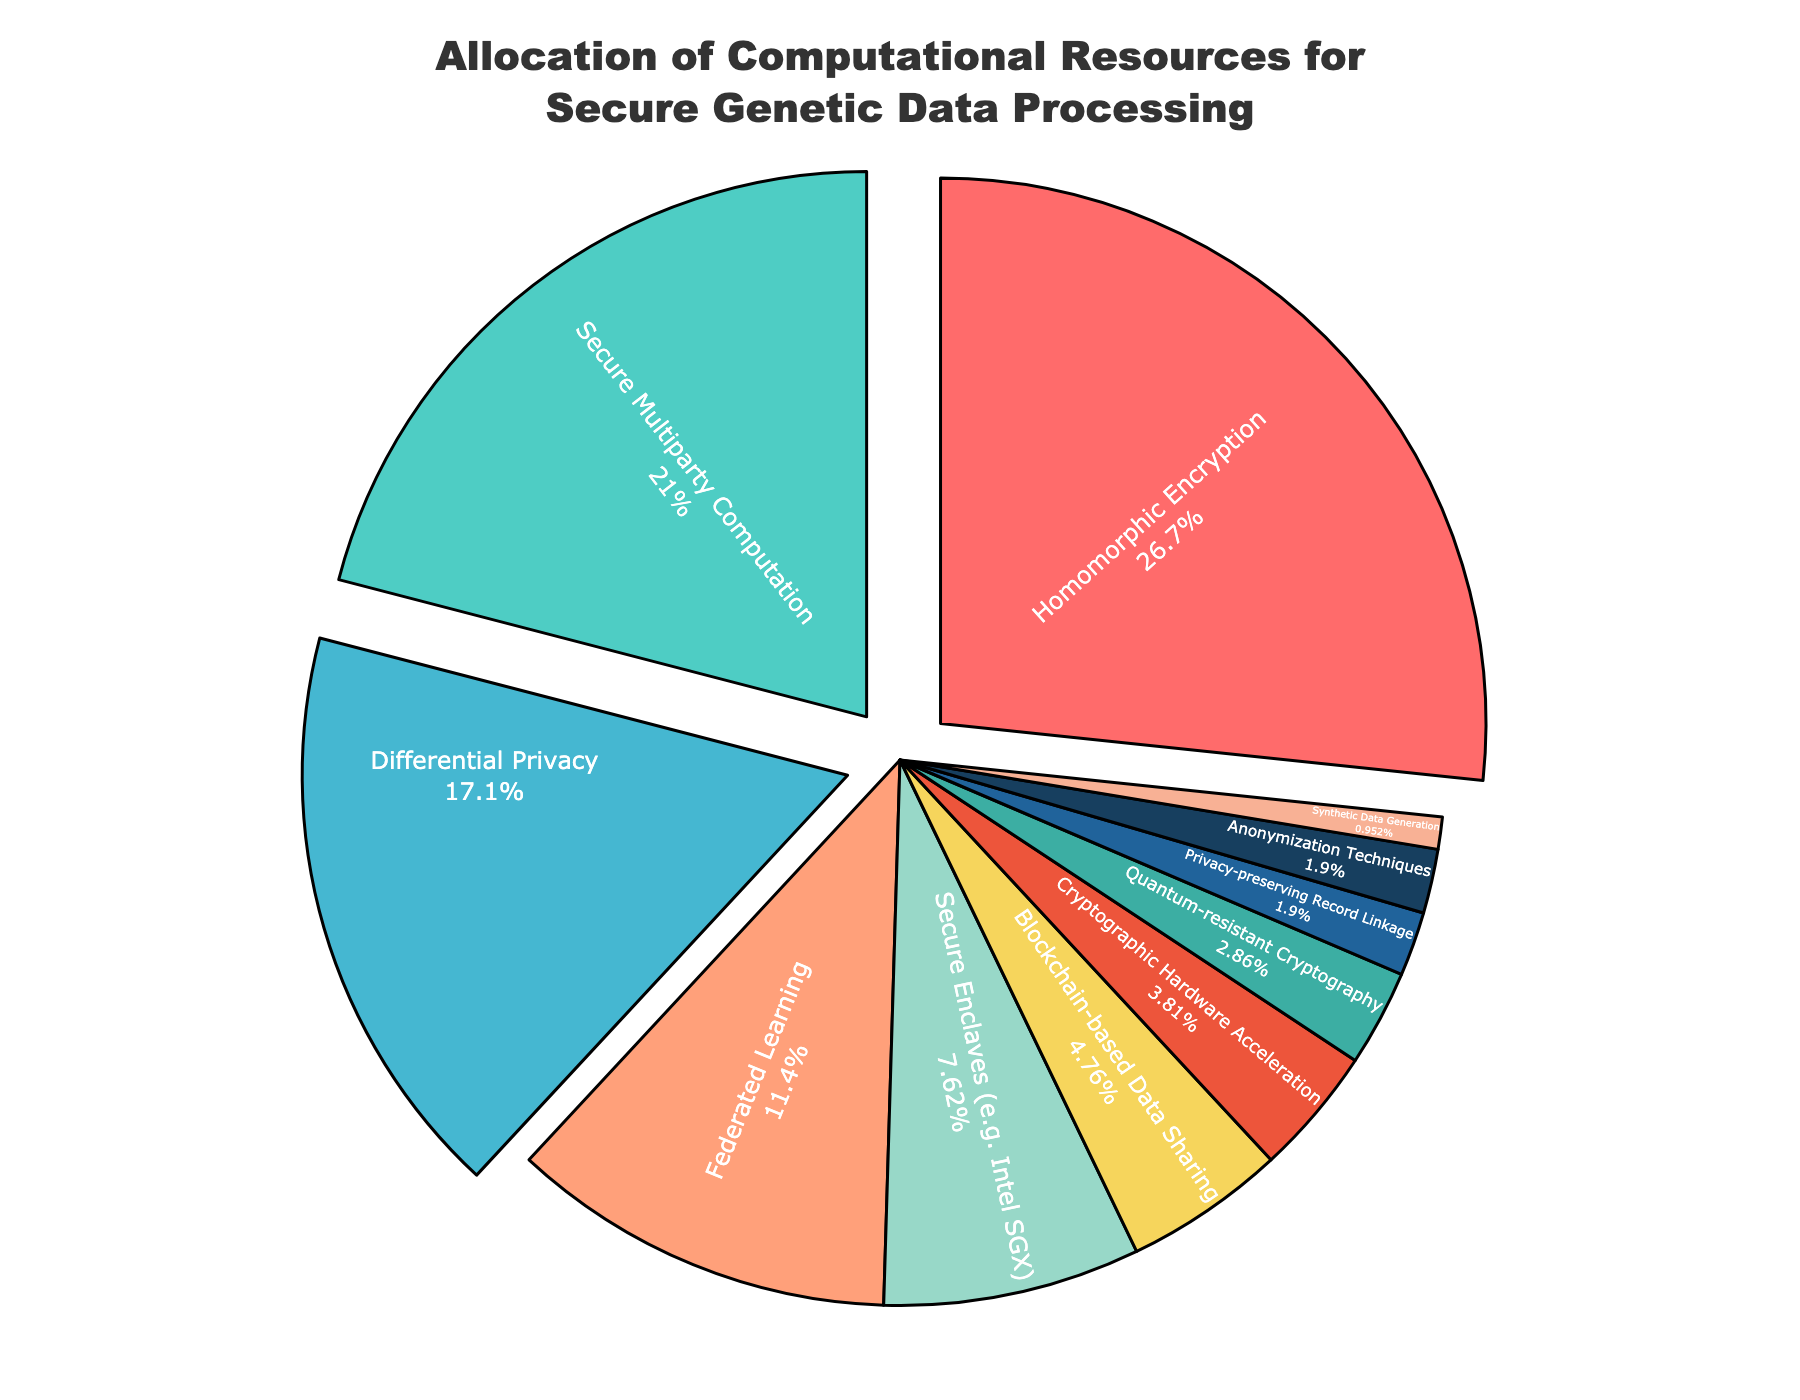What resource receives the highest allocation? The largest slice of the pie chart represents the resource receiving the highest allocation. The segment for Homomorphic Encryption is the largest at 28%.
Answer: Homomorphic Encryption What is the combined percentage of resources allocated to Secure Multiparty Computation and Differential Privacy? Add the percentages of Secure Multiparty Computation (22%) and Differential Privacy (18%) to find the total. 22% + 18% = 40%.
Answer: 40% Which resources have the same allocation percentage? Look for segments in the pie chart with equal sizes. Privacy-preserving Record Linkage and Anonymization Techniques both have a 2% allocation.
Answer: Privacy-preserving Record Linkage and Anonymization Techniques What is the difference in allocation between Federated Learning and Secure Enclaves? Subtract the percentage of Secure Enclaves (8%) from Federated Learning's percentage (12%). 12% - 8% = 4%.
Answer: 4% Which resource has the smallest allocation, and what is its percentage? Identify the smallest segment in the pie chart, which represents Synthetic Data Generation at 1%.
Answer: Synthetic Data Generation, 1% What is the combined percentage allocation of the three smallest resources? Add the percentages of the smallest three resources: Synthetic Data Generation (1%), Privacy-preserving Record Linkage (2%), and Anonymization Techniques (2%). 1% + 2% + 2% = 5%.
Answer: 5% Which categories have a higher allocation than Cryptographic Hardware Acceleration? Compare the percentages of all resources to Cryptographic Hardware Acceleration's 4%. Higher allocations are Homomorphic Encryption (28%), Secure Multiparty Computation (22%), Differential Privacy (18%), Federated Learning (12%), and Secure Enclaves (8%).
Answer: Homomorphic Encryption, Secure Multiparty Computation, Differential Privacy, Federated Learning, Secure Enclaves What is the total allocation percentage of resources related to cryptography? Sum the percentages for Homomorphic Encryption (28%), Cryptographic Hardware Acceleration (4%), Quantum-resistant Cryptography (3%), andBlockchain-based Data Sharing (5%). 28% + 4% + 3% + 5% = 40%.
Answer: 40% Is the allocation for Secure Enclaves greater than that for Blockchain-based Data Sharing? Compare the two percentages: Secure Enclaves (8%) and Blockchain-based Data Sharing (5%). 8% is greater than 5%.
Answer: Yes What is the average allocation percentage for all resources? Sum all the percentages and divide by the number of resources. If we sum up all the given percentages, we get 100%. There are 11 resources, so 100% / 11 = approximately 9.09%.
Answer: 9.09% 